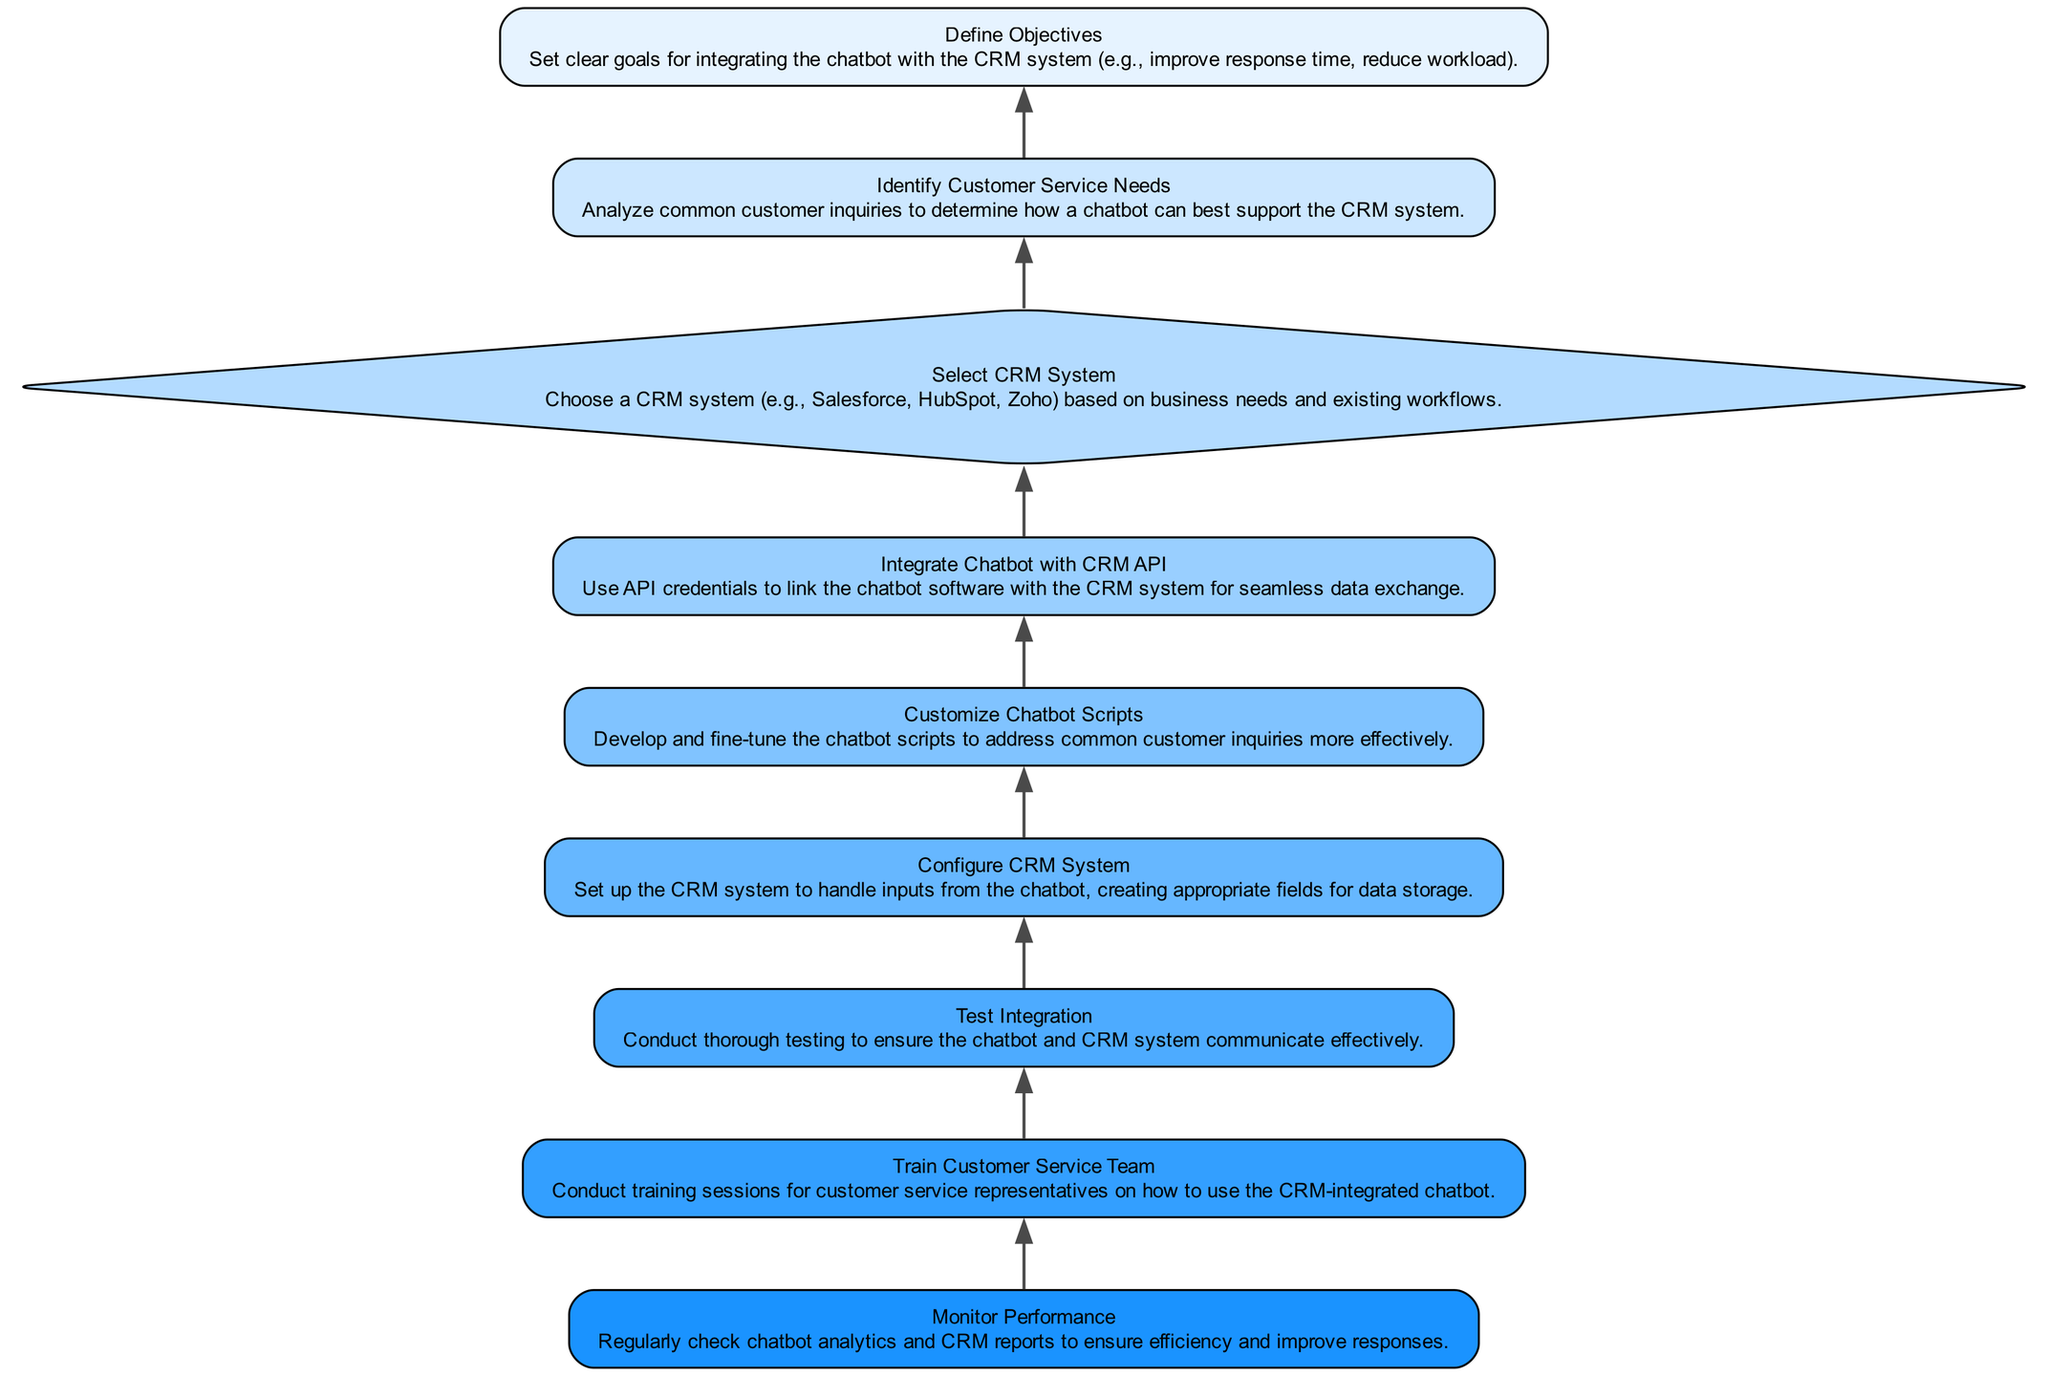What is the first task in the flow? The first task listed at the bottom of the diagram is "Define Objectives" which establishes the goals for integration.
Answer: Define Objectives How many tasks are present in the flow? By counting the nodes designated as tasks in the diagram, there are a total of six tasks.
Answer: Six Which task comes immediately after "Select CRM System"? The next task in the order following "Select CRM System" is "Integrate Chatbot with CRM API".
Answer: Integrate Chatbot with CRM API What type of element is "Select CRM System"? This element is categorized as a decision in the diagram.
Answer: Decision What is the purpose of "Train Customer Service Team"? The description indicates that this task aims to educate customer service representatives on using the integrated chatbot effectively.
Answer: Conduct training sessions for customer service representatives What connects "Monitor Performance" and "Train Customer Service Team"? The directed edge (connection) from "Train Customer Service Team" to "Monitor Performance" indicates that after training, performance should be monitored.
Answer: Directed edge How is the chatbot integrated with the CRM system? The integration is accomplished through using API credentials to link the chatbot and CRM for data exchange.
Answer: Use API credentials What is the final step in the flow? The last step in the sequence is "Monitor Performance", which focuses on the ongoing evaluation of chatbot and CRM performance.
Answer: Monitor Performance 